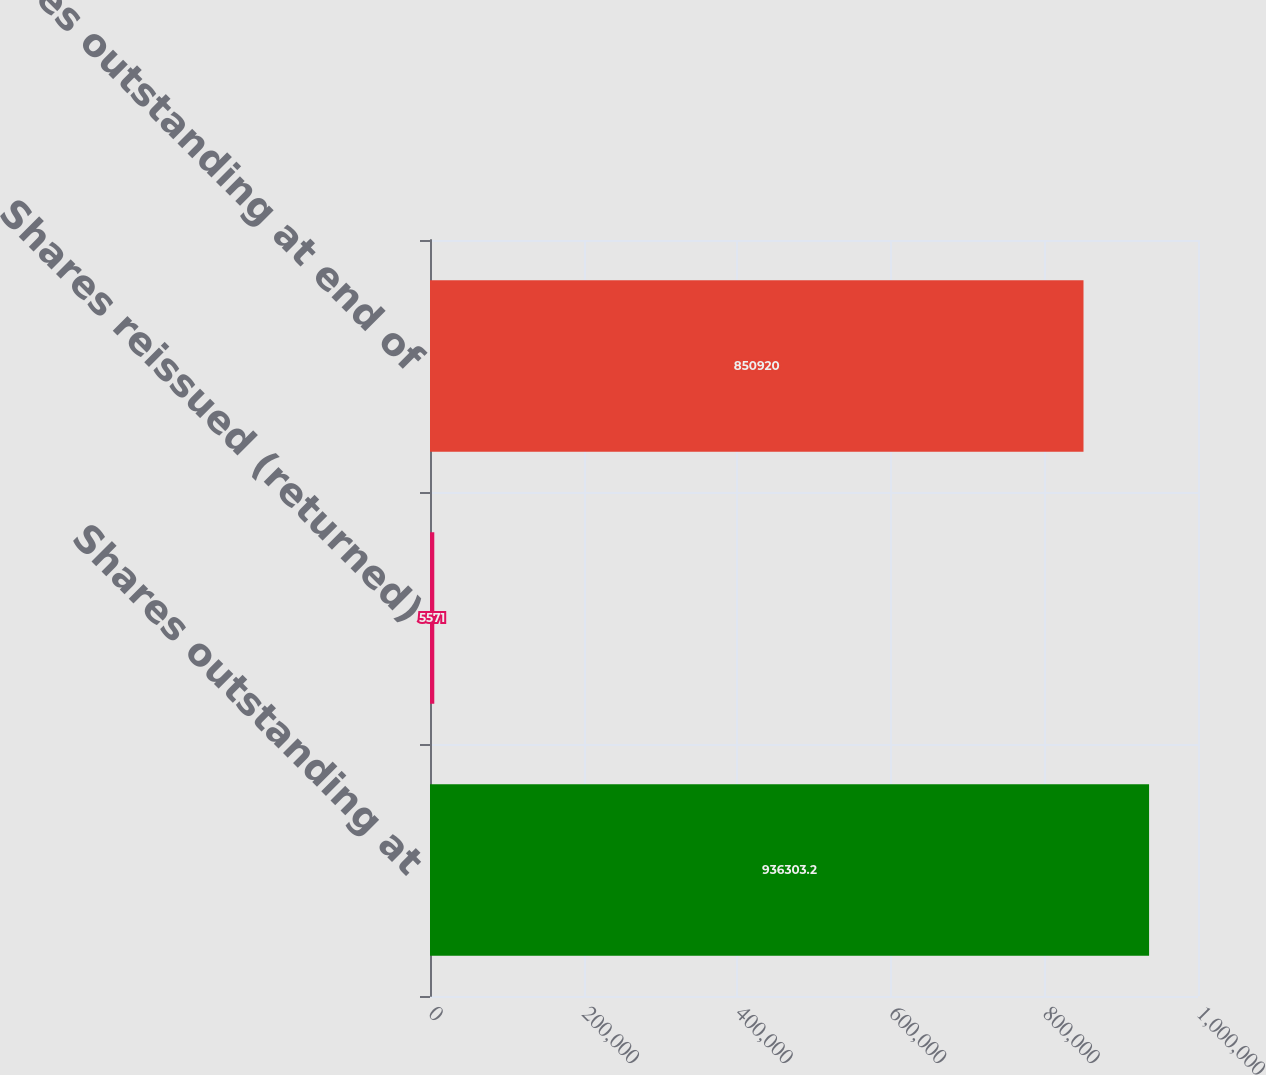Convert chart to OTSL. <chart><loc_0><loc_0><loc_500><loc_500><bar_chart><fcel>Shares outstanding at<fcel>Shares reissued (returned)<fcel>Shares outstanding at end of<nl><fcel>936303<fcel>5571<fcel>850920<nl></chart> 